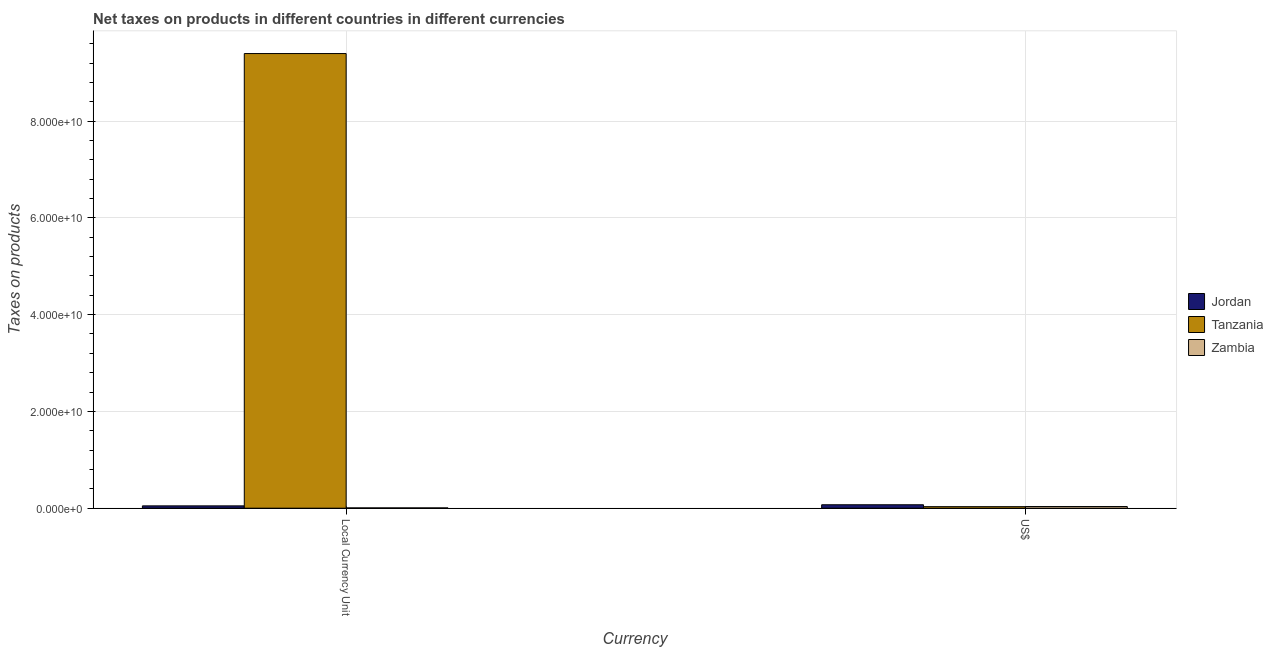How many different coloured bars are there?
Make the answer very short. 3. How many groups of bars are there?
Provide a short and direct response. 2. How many bars are there on the 1st tick from the left?
Provide a succinct answer. 3. How many bars are there on the 2nd tick from the right?
Ensure brevity in your answer.  3. What is the label of the 2nd group of bars from the left?
Ensure brevity in your answer.  US$. What is the net taxes in us$ in Tanzania?
Provide a short and direct response. 3.16e+08. Across all countries, what is the maximum net taxes in us$?
Provide a short and direct response. 7.08e+08. Across all countries, what is the minimum net taxes in us$?
Offer a terse response. 3.16e+08. In which country was the net taxes in constant 2005 us$ maximum?
Make the answer very short. Tanzania. In which country was the net taxes in constant 2005 us$ minimum?
Offer a very short reply. Zambia. What is the total net taxes in constant 2005 us$ in the graph?
Your answer should be compact. 9.45e+1. What is the difference between the net taxes in us$ in Zambia and that in Tanzania?
Give a very brief answer. 2.45e+07. What is the difference between the net taxes in us$ in Zambia and the net taxes in constant 2005 us$ in Jordan?
Give a very brief answer. -1.41e+08. What is the average net taxes in us$ per country?
Keep it short and to the point. 4.55e+08. What is the difference between the net taxes in constant 2005 us$ and net taxes in us$ in Tanzania?
Give a very brief answer. 9.36e+1. In how many countries, is the net taxes in constant 2005 us$ greater than 48000000000 units?
Ensure brevity in your answer.  1. What is the ratio of the net taxes in us$ in Tanzania to that in Jordan?
Provide a succinct answer. 0.45. What does the 2nd bar from the left in US$ represents?
Offer a terse response. Tanzania. What does the 2nd bar from the right in Local Currency Unit represents?
Provide a succinct answer. Tanzania. How many bars are there?
Keep it short and to the point. 6. Are all the bars in the graph horizontal?
Ensure brevity in your answer.  No. What is the difference between two consecutive major ticks on the Y-axis?
Give a very brief answer. 2.00e+1. Does the graph contain grids?
Give a very brief answer. Yes. How are the legend labels stacked?
Ensure brevity in your answer.  Vertical. What is the title of the graph?
Your answer should be very brief. Net taxes on products in different countries in different currencies. What is the label or title of the X-axis?
Your answer should be compact. Currency. What is the label or title of the Y-axis?
Provide a succinct answer. Taxes on products. What is the Taxes on products in Jordan in Local Currency Unit?
Your response must be concise. 4.82e+08. What is the Taxes on products in Tanzania in Local Currency Unit?
Make the answer very short. 9.40e+1. What is the Taxes on products in Zambia in Local Currency Unit?
Provide a succinct answer. 6.09e+07. What is the Taxes on products of Jordan in US$?
Offer a very short reply. 7.08e+08. What is the Taxes on products of Tanzania in US$?
Your answer should be compact. 3.16e+08. What is the Taxes on products in Zambia in US$?
Provide a succinct answer. 3.40e+08. Across all Currency, what is the maximum Taxes on products in Jordan?
Your response must be concise. 7.08e+08. Across all Currency, what is the maximum Taxes on products of Tanzania?
Offer a very short reply. 9.40e+1. Across all Currency, what is the maximum Taxes on products of Zambia?
Your answer should be compact. 3.40e+08. Across all Currency, what is the minimum Taxes on products of Jordan?
Ensure brevity in your answer.  4.82e+08. Across all Currency, what is the minimum Taxes on products of Tanzania?
Make the answer very short. 3.16e+08. Across all Currency, what is the minimum Taxes on products of Zambia?
Keep it short and to the point. 6.09e+07. What is the total Taxes on products in Jordan in the graph?
Your answer should be very brief. 1.19e+09. What is the total Taxes on products in Tanzania in the graph?
Offer a very short reply. 9.43e+1. What is the total Taxes on products in Zambia in the graph?
Provide a succinct answer. 4.01e+08. What is the difference between the Taxes on products of Jordan in Local Currency Unit and that in US$?
Your response must be concise. -2.27e+08. What is the difference between the Taxes on products in Tanzania in Local Currency Unit and that in US$?
Make the answer very short. 9.36e+1. What is the difference between the Taxes on products in Zambia in Local Currency Unit and that in US$?
Offer a terse response. -2.79e+08. What is the difference between the Taxes on products of Jordan in Local Currency Unit and the Taxes on products of Tanzania in US$?
Provide a succinct answer. 1.66e+08. What is the difference between the Taxes on products of Jordan in Local Currency Unit and the Taxes on products of Zambia in US$?
Make the answer very short. 1.41e+08. What is the difference between the Taxes on products in Tanzania in Local Currency Unit and the Taxes on products in Zambia in US$?
Keep it short and to the point. 9.36e+1. What is the average Taxes on products in Jordan per Currency?
Offer a very short reply. 5.95e+08. What is the average Taxes on products in Tanzania per Currency?
Provide a short and direct response. 4.71e+1. What is the average Taxes on products of Zambia per Currency?
Your answer should be very brief. 2.01e+08. What is the difference between the Taxes on products in Jordan and Taxes on products in Tanzania in Local Currency Unit?
Your answer should be compact. -9.35e+1. What is the difference between the Taxes on products in Jordan and Taxes on products in Zambia in Local Currency Unit?
Ensure brevity in your answer.  4.21e+08. What is the difference between the Taxes on products of Tanzania and Taxes on products of Zambia in Local Currency Unit?
Your answer should be compact. 9.39e+1. What is the difference between the Taxes on products of Jordan and Taxes on products of Tanzania in US$?
Make the answer very short. 3.93e+08. What is the difference between the Taxes on products of Jordan and Taxes on products of Zambia in US$?
Offer a terse response. 3.68e+08. What is the difference between the Taxes on products of Tanzania and Taxes on products of Zambia in US$?
Give a very brief answer. -2.45e+07. What is the ratio of the Taxes on products in Jordan in Local Currency Unit to that in US$?
Offer a very short reply. 0.68. What is the ratio of the Taxes on products in Tanzania in Local Currency Unit to that in US$?
Make the answer very short. 297.71. What is the ratio of the Taxes on products of Zambia in Local Currency Unit to that in US$?
Offer a terse response. 0.18. What is the difference between the highest and the second highest Taxes on products in Jordan?
Keep it short and to the point. 2.27e+08. What is the difference between the highest and the second highest Taxes on products in Tanzania?
Your answer should be very brief. 9.36e+1. What is the difference between the highest and the second highest Taxes on products in Zambia?
Offer a terse response. 2.79e+08. What is the difference between the highest and the lowest Taxes on products in Jordan?
Keep it short and to the point. 2.27e+08. What is the difference between the highest and the lowest Taxes on products of Tanzania?
Provide a short and direct response. 9.36e+1. What is the difference between the highest and the lowest Taxes on products in Zambia?
Make the answer very short. 2.79e+08. 